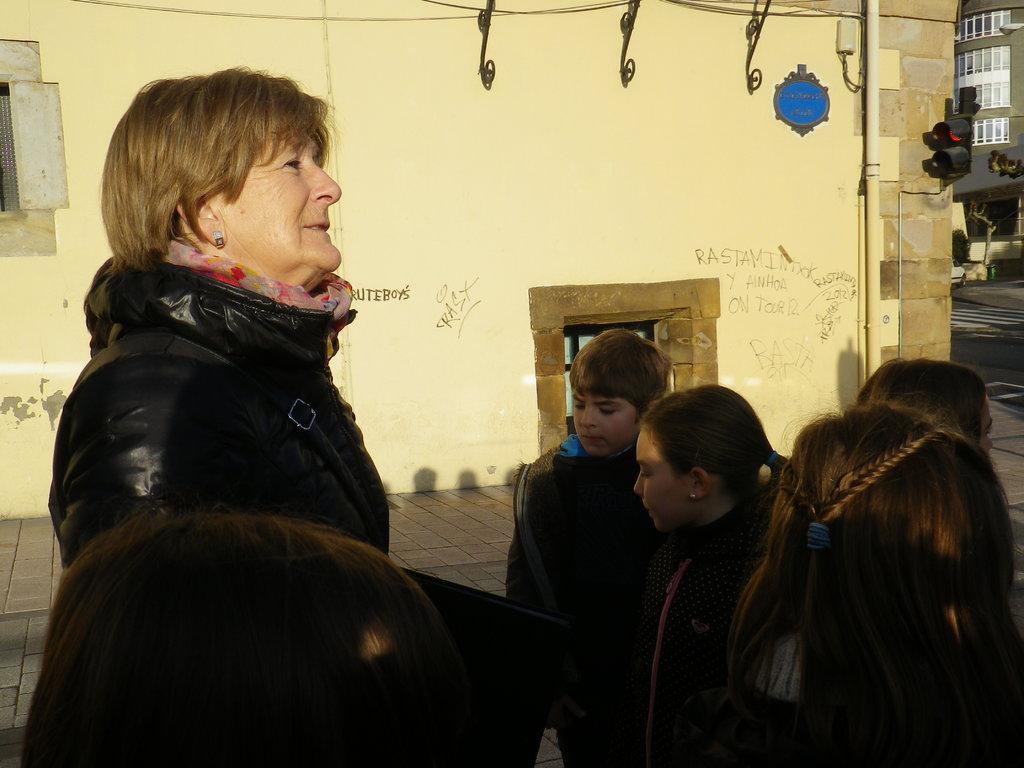Please provide a concise description of this image. In this image we can see a lady standing. She is wearing a jacket and there are kids. In the background there are buildings. On the right we can see traffic lights. 